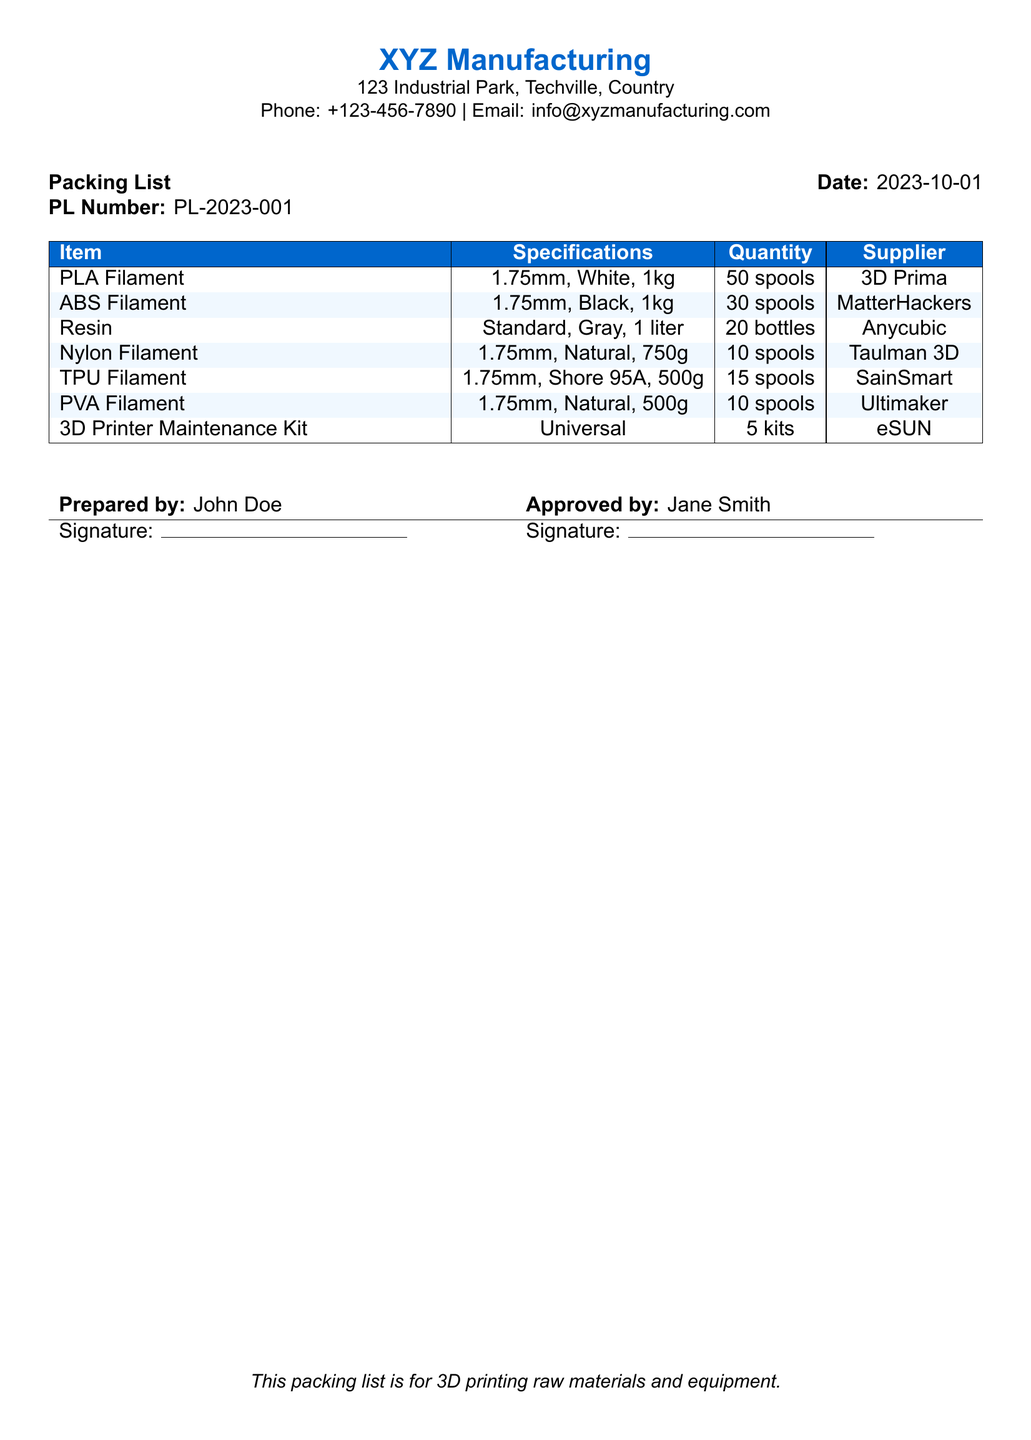What is the date of the packing list? The date can be found in the document header, indicating when the packing list was created.
Answer: 2023-10-01 Who prepared the packing list? This information is located in the footer section, under the "Prepared by" label.
Answer: John Doe What is the quantity of PLA Filament? This information is found in the table, identifying how many spools of PLA Filament are included.
Answer: 50 spools Which supplier provides the Nylon Filament? The supplier name is listed in the corresponding row for Nylon Filament within the table.
Answer: Taulman 3D How many types of filament are listed in the packing list? This requires counting the different filament types listed in the document.
Answer: 5 types What is the specification of the TPU Filament? The specification details are provided in the row dedicated to TPU Filament in the table.
Answer: 1.75mm, Shore 95A, 500g What is the total quantity of resin included? The total quantity is stated in the table under the Resin entry.
Answer: 20 bottles Who approved the packing list? This information is found in the footer section under the "Approved by" label.
Answer: Jane Smith What item is listed under "3D Printer Maintenance Kit"? The specific item is mentioned clearly in the table under its own row.
Answer: Universal 